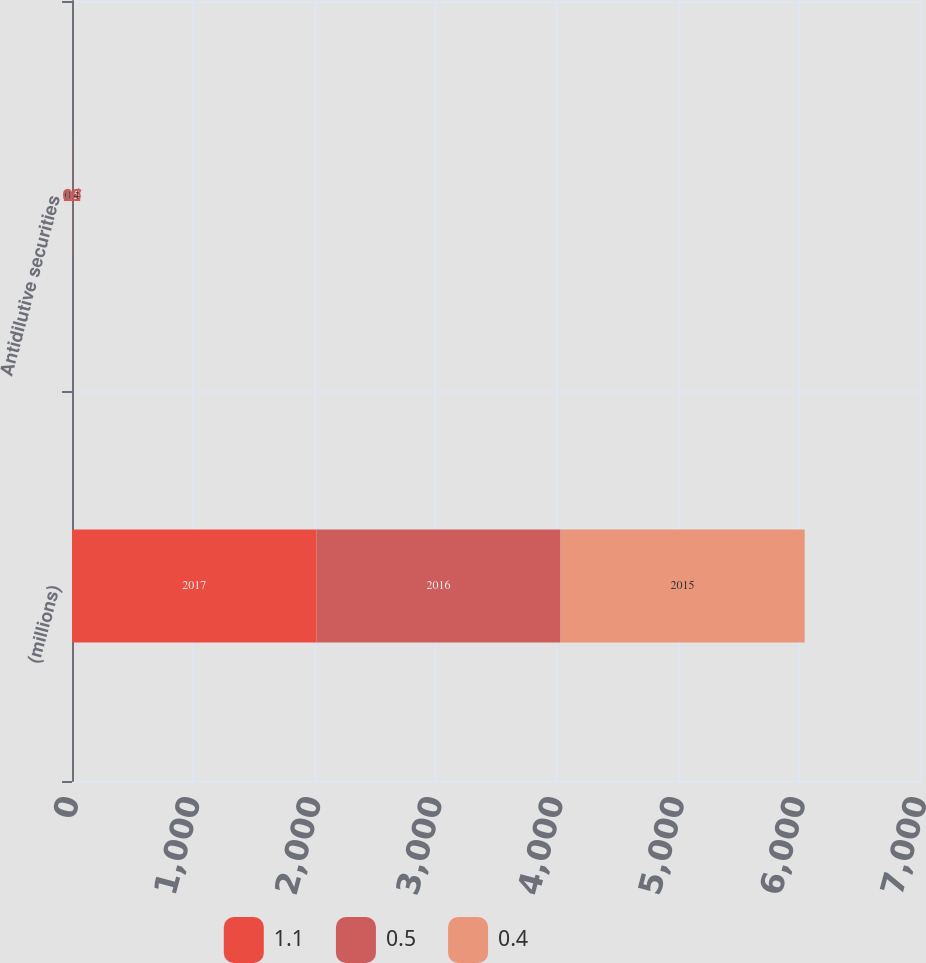Convert chart to OTSL. <chart><loc_0><loc_0><loc_500><loc_500><stacked_bar_chart><ecel><fcel>(millions)<fcel>Antidilutive securities<nl><fcel>1.1<fcel>2017<fcel>1.1<nl><fcel>0.5<fcel>2016<fcel>0.5<nl><fcel>0.4<fcel>2015<fcel>0.4<nl></chart> 